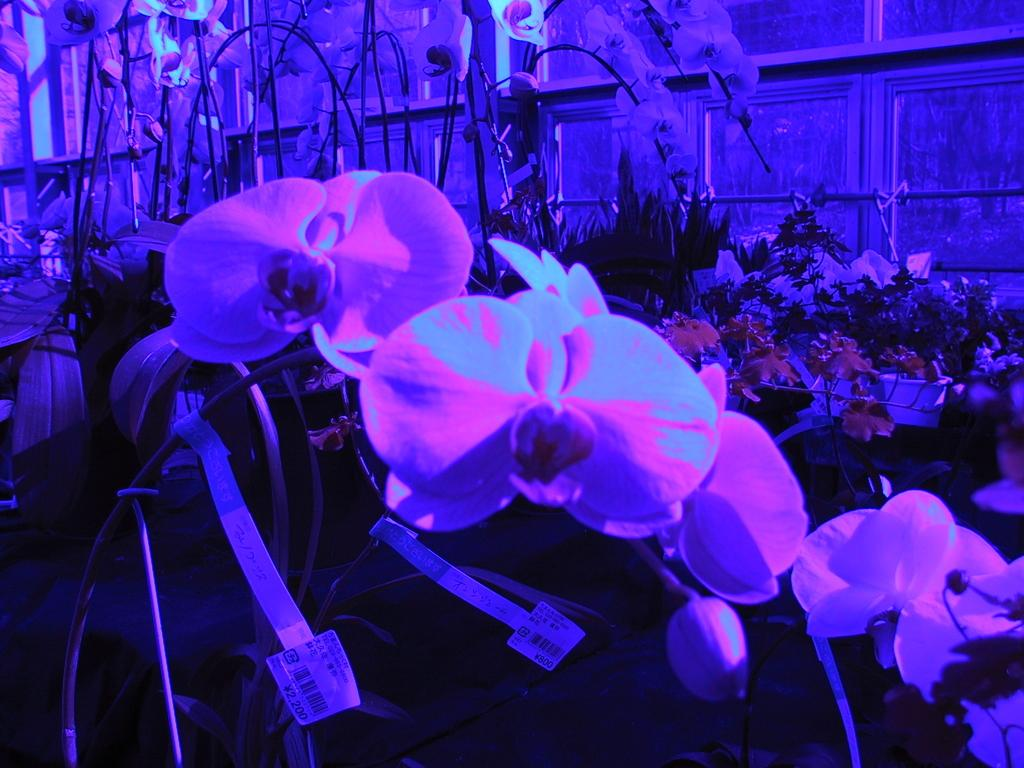What type of plants are present in the image? The image contains plants with flowers. What additional information is provided at the bottom of the image? There are tags at the bottom of the image. What are the tags associated with? The tags are associated with an object. What can be seen in the background of the image? There are glass windows in the background of the image. How many seats are available for passengers in the image? There are no seats or trains present in the image; it features plants with flowers and tags. 